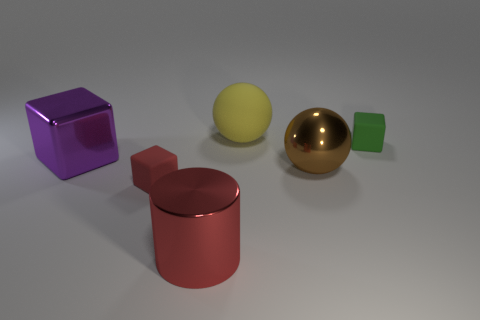Are there any other things that are the same shape as the large red metallic object?
Your answer should be very brief. No. Do the block that is on the left side of the red rubber thing and the yellow thing have the same material?
Ensure brevity in your answer.  No. There is a red thing that is the same size as the brown sphere; what is its material?
Give a very brief answer. Metal. How many other things are the same material as the large purple thing?
Make the answer very short. 2. There is a red matte object; is its size the same as the rubber cube that is on the right side of the red block?
Provide a succinct answer. Yes. Are there fewer large cubes behind the green matte cube than balls that are in front of the purple metal cube?
Your answer should be very brief. Yes. How big is the matte block behind the red matte object?
Your answer should be very brief. Small. Is the green cube the same size as the red block?
Ensure brevity in your answer.  Yes. How many things are both right of the yellow rubber thing and in front of the green block?
Give a very brief answer. 1. How many red objects are spheres or small matte blocks?
Ensure brevity in your answer.  1. 